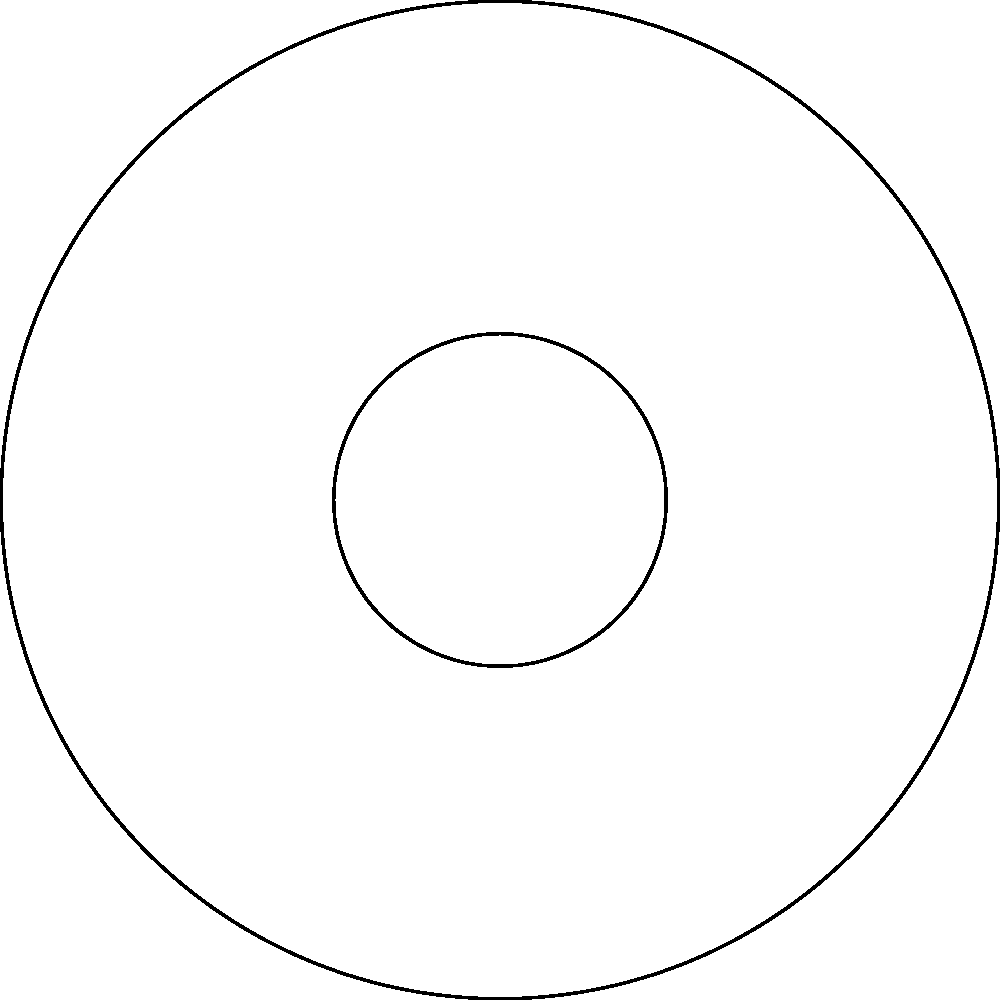In the polar coordinate system shown, three ancient astronomical alignments are plotted: A $(3, 30^\circ)$, B $(4, 150^\circ)$, and C $(5, 270^\circ)$. Which alignment is closest to the origin, and what is its distance from the origin? To determine which alignment is closest to the origin and its distance, we need to compare the radial distances (r) of each point:

1. Point A: $r_A = 3$
2. Point B: $r_B = 4$
3. Point C: $r_C = 5$

The angular coordinates (θ) do not affect the distance from the origin in a polar coordinate system. The radial coordinate (r) directly represents the distance from the origin.

Comparing the radial distances:
$r_A < r_B < r_C$

Therefore, point A is closest to the origin with a distance of 3 units.
Answer: A, 3 units 